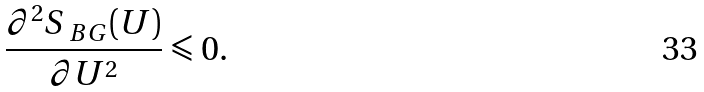<formula> <loc_0><loc_0><loc_500><loc_500>\frac { \partial ^ { 2 } S _ { \ B G } ( U ) } { \partial U ^ { 2 } } \leqslant 0 .</formula> 